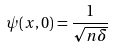<formula> <loc_0><loc_0><loc_500><loc_500>\psi ( x , 0 ) = \frac { 1 } { \sqrt { n \delta } }</formula> 